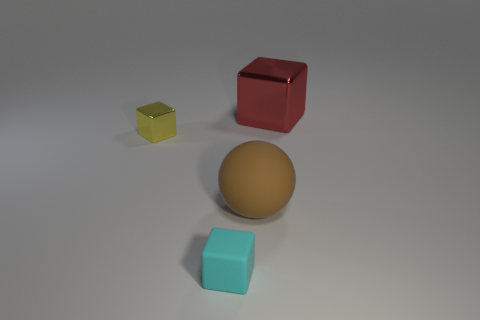Subtract all yellow metallic blocks. How many blocks are left? 2 Add 4 red rubber balls. How many objects exist? 8 Subtract all yellow blocks. How many blocks are left? 2 Subtract all cubes. How many objects are left? 1 Subtract all yellow spheres. Subtract all cyan cubes. How many spheres are left? 1 Subtract all yellow things. Subtract all matte cubes. How many objects are left? 2 Add 3 brown matte objects. How many brown matte objects are left? 4 Add 2 large purple rubber blocks. How many large purple rubber blocks exist? 2 Subtract 0 purple cylinders. How many objects are left? 4 Subtract 1 spheres. How many spheres are left? 0 